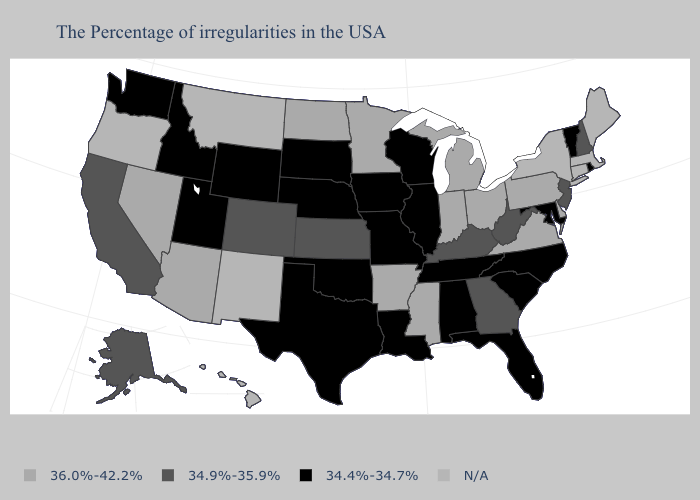What is the value of Nebraska?
Be succinct. 34.4%-34.7%. Among the states that border Louisiana , which have the highest value?
Short answer required. Mississippi, Arkansas. Name the states that have a value in the range N/A?
Keep it brief. Maine, Massachusetts, Connecticut, New York, New Mexico, Montana, Oregon, Hawaii. Is the legend a continuous bar?
Answer briefly. No. Among the states that border Colorado , which have the lowest value?
Be succinct. Nebraska, Oklahoma, Wyoming, Utah. Name the states that have a value in the range 34.4%-34.7%?
Keep it brief. Rhode Island, Vermont, Maryland, North Carolina, South Carolina, Florida, Alabama, Tennessee, Wisconsin, Illinois, Louisiana, Missouri, Iowa, Nebraska, Oklahoma, Texas, South Dakota, Wyoming, Utah, Idaho, Washington. Does Ohio have the highest value in the USA?
Answer briefly. Yes. What is the lowest value in the Northeast?
Answer briefly. 34.4%-34.7%. What is the highest value in states that border Vermont?
Quick response, please. 34.9%-35.9%. Name the states that have a value in the range 34.9%-35.9%?
Keep it brief. New Hampshire, New Jersey, West Virginia, Georgia, Kentucky, Kansas, Colorado, California, Alaska. Name the states that have a value in the range 36.0%-42.2%?
Be succinct. Delaware, Pennsylvania, Virginia, Ohio, Michigan, Indiana, Mississippi, Arkansas, Minnesota, North Dakota, Arizona, Nevada. What is the value of Oregon?
Short answer required. N/A. What is the highest value in states that border New York?
Quick response, please. 36.0%-42.2%. What is the value of Rhode Island?
Quick response, please. 34.4%-34.7%. 